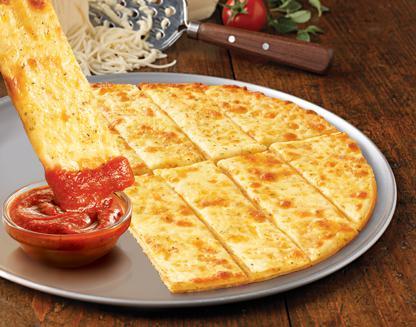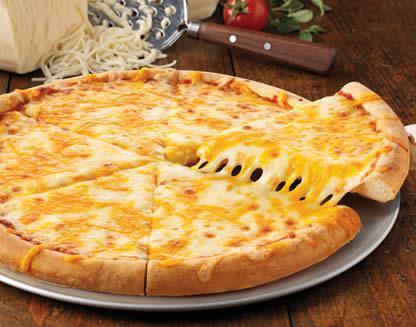The first image is the image on the left, the second image is the image on the right. Given the left and right images, does the statement "The left image includes a round shape with a type of pizza food depicted on it, and the right image shows fast food in a squarish container." hold true? Answer yes or no. No. The first image is the image on the left, the second image is the image on the right. Given the left and right images, does the statement "One of the images shows pepperoni." hold true? Answer yes or no. No. 